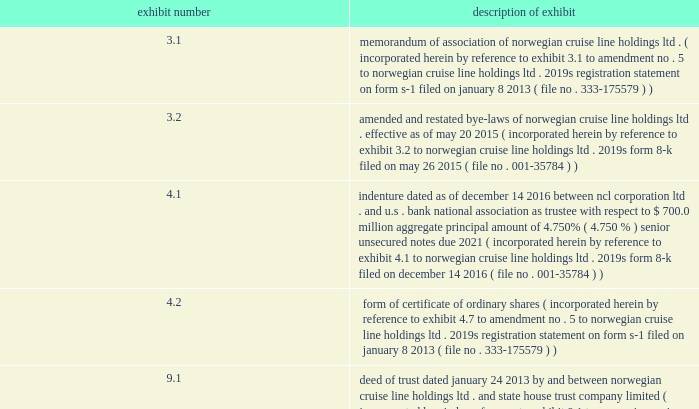Part iv item 15 .
Exhibits , financial statement schedules ( 1 ) financial statements our consolidated financial statements have been prepared in accordance with item 8 .
Financial statements and supplementary data and are included beginning on page f-1 of this report .
( 2 ) financial statement schedules schedule ii : valuation and qualifying accounts for the three years ended december 31 , 2018 are included on page 61 .
( 3 ) exhibits the exhibits listed below are filed or incorporated by reference as part of this annual report on form 10-k .
Index to exhibits exhibit number description of exhibit 3.1 memorandum of association of norwegian cruise line holdings ltd .
( incorporated herein by reference to exhibit 3.1 to amendment no .
5 to norwegian cruise line holdings ltd . 2019s registration statement on form s-1 filed on january 8 , 2013 ( file no .
333-175579 ) ) 3.2 amended and restated bye-laws of norwegian cruise line holdings ltd. , effective as of may 20 , 2015 ( incorporated herein by reference to exhibit 3.2 to norwegian cruise line holdings ltd . 2019s form 8-k filed on may 26 , 2015 ( file no .
001-35784 ) ) 4.1 indenture , dated as of december 14 , 2016 , between ncl corporation ltd .
And u.s .
Bank national association , as trustee with respect to $ 700.0 million aggregate principal amount of 4.750% ( 4.750 % ) senior unsecured notes due 2021 ( incorporated herein by reference to exhibit 4.1 to norwegian cruise line holdings ltd . 2019s form 8-k filed on december 14 , 2016 ( file no .
001- 35784 ) ) 4.2 form of certificate of ordinary shares ( incorporated herein by reference to exhibit 4.7 to amendment no .
5 to norwegian cruise line holdings ltd . 2019s registration statement on form s-1 filed on january 8 , 2013 ( file no .
333-175579 ) ) 9.1 deed of trust , dated january 24 , 2013 , by and between norwegian cruise line holdings ltd .
And state house trust company limited ( incorporated herein by reference to exhibit 9.1 to norwegian cruise line holdings ltd . 2019s form 8-k filed on january 30 , 2013 ( file no .
001-35784 ) ) 10.1 sixth supplemental deed , dated june 1 , 2012 , to 20ac662.9 million norwegian epic loan , dated as of september 22 , 2006 , as amended , by and among f3 two , ltd. , ncl corporation ltd .
And a syndicate of international banks and related amended and restated guarantee by ncl corporation ltd .
( incorporated herein by reference to exhibit 10.5 to ncl corporation ltd . 2019s report on form 6-k/a filed on january 8 , 2013 ( file no .
333-128780 ) ) + 2020 10.2 letter , dated november 27 , 2015 , amending 20ac662.9 million norwegian epic loan , dated as of september 22 , 2006 , as amended , by and among norwegian epic , ltd .
( formerly f3 two , ltd. ) , ncl corporation ltd .
And a syndicate of international banks and related amended and restated guarantee by ncl corporation ltd .
( incorporated herein by reference to exhibit 10.5 to norwegian cruise line holdings ltd . 2019s form 10-k filed on february 29 , 2016 ( file no .
001-35784 ) ) 10.3 office lease agreement , dated as of november 27 , 2006 , by and between ncl ( bahamas ) ltd .
And hines reit airport corporate center llc and related guarantee by ncl corporation ltd. , and first amendment , dated november 27 , 2006 ( incorporated herein by reference to exhibit 4.46 to ncl corporation ltd . 2019s annual report on form 20-f filed on march 6 , 2007 ( file no .
333-128780 ) ) + .
Part iv item 15 .
Exhibits , financial statement schedules ( 1 ) financial statements our consolidated financial statements have been prepared in accordance with item 8 .
Financial statements and supplementary data and are included beginning on page f-1 of this report .
( 2 ) financial statement schedules schedule ii : valuation and qualifying accounts for the three years ended december 31 , 2018 are included on page 61 .
( 3 ) exhibits the exhibits listed below are filed or incorporated by reference as part of this annual report on form 10-k .
Index to exhibits exhibit number description of exhibit 3.1 memorandum of association of norwegian cruise line holdings ltd .
( incorporated herein by reference to exhibit 3.1 to amendment no .
5 to norwegian cruise line holdings ltd . 2019s registration statement on form s-1 filed on january 8 , 2013 ( file no .
333-175579 ) ) 3.2 amended and restated bye-laws of norwegian cruise line holdings ltd. , effective as of may 20 , 2015 ( incorporated herein by reference to exhibit 3.2 to norwegian cruise line holdings ltd . 2019s form 8-k filed on may 26 , 2015 ( file no .
001-35784 ) ) 4.1 indenture , dated as of december 14 , 2016 , between ncl corporation ltd .
And u.s .
Bank national association , as trustee with respect to $ 700.0 million aggregate principal amount of 4.750% ( 4.750 % ) senior unsecured notes due 2021 ( incorporated herein by reference to exhibit 4.1 to norwegian cruise line holdings ltd . 2019s form 8-k filed on december 14 , 2016 ( file no .
001- 35784 ) ) 4.2 form of certificate of ordinary shares ( incorporated herein by reference to exhibit 4.7 to amendment no .
5 to norwegian cruise line holdings ltd . 2019s registration statement on form s-1 filed on january 8 , 2013 ( file no .
333-175579 ) ) 9.1 deed of trust , dated january 24 , 2013 , by and between norwegian cruise line holdings ltd .
And state house trust company limited ( incorporated herein by reference to exhibit 9.1 to norwegian cruise line holdings ltd . 2019s form 8-k filed on january 30 , 2013 ( file no .
001-35784 ) ) 10.1 sixth supplemental deed , dated june 1 , 2012 , to 20ac662.9 million norwegian epic loan , dated as of september 22 , 2006 , as amended , by and among f3 two , ltd. , ncl corporation ltd .
And a syndicate of international banks and related amended and restated guarantee by ncl corporation ltd .
( incorporated herein by reference to exhibit 10.5 to ncl corporation ltd . 2019s report on form 6-k/a filed on january 8 , 2013 ( file no .
333-128780 ) ) + 2020 10.2 letter , dated november 27 , 2015 , amending 20ac662.9 million norwegian epic loan , dated as of september 22 , 2006 , as amended , by and among norwegian epic , ltd .
( formerly f3 two , ltd. ) , ncl corporation ltd .
And a syndicate of international banks and related amended and restated guarantee by ncl corporation ltd .
( incorporated herein by reference to exhibit 10.5 to norwegian cruise line holdings ltd . 2019s form 10-k filed on february 29 , 2016 ( file no .
001-35784 ) ) 10.3 office lease agreement , dated as of november 27 , 2006 , by and between ncl ( bahamas ) ltd .
And hines reit airport corporate center llc and related guarantee by ncl corporation ltd. , and first amendment , dated november 27 , 2006 ( incorporated herein by reference to exhibit 4.46 to ncl corporation ltd . 2019s annual report on form 20-f filed on march 6 , 2007 ( file no .
333-128780 ) ) + .
What will the payment of interest be on the 2021 senior unsecure note? 
Rationale: to find the payment on interest one would multiple the amount by the interest rate .
Computations: (700.0 * 4.750%)
Answer: 33.25. 